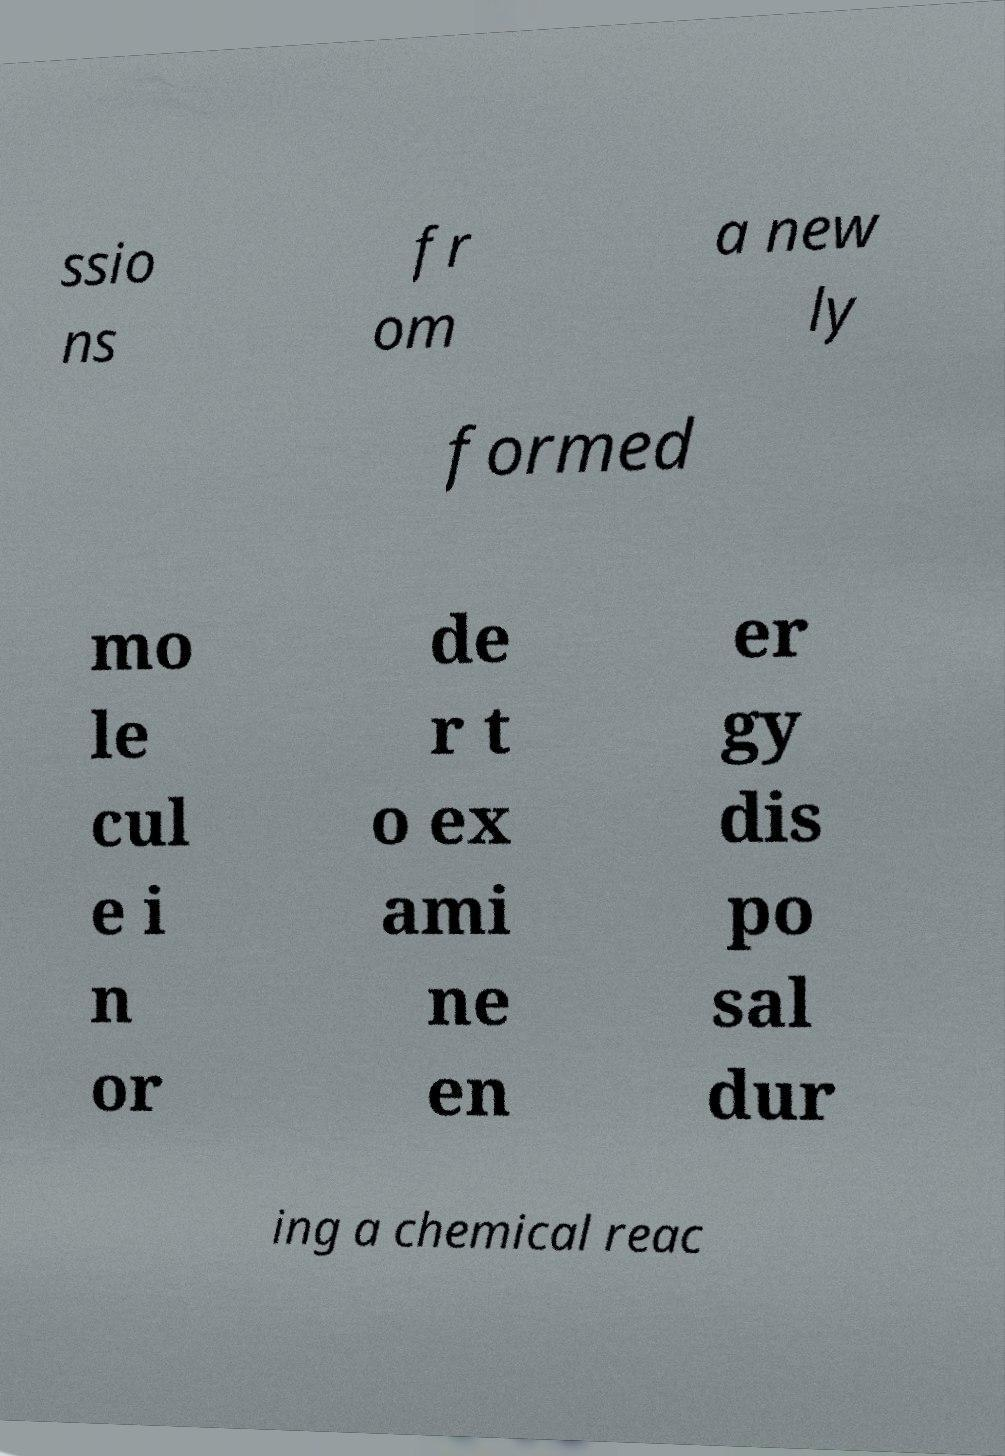Please read and relay the text visible in this image. What does it say? ssio ns fr om a new ly formed mo le cul e i n or de r t o ex ami ne en er gy dis po sal dur ing a chemical reac 